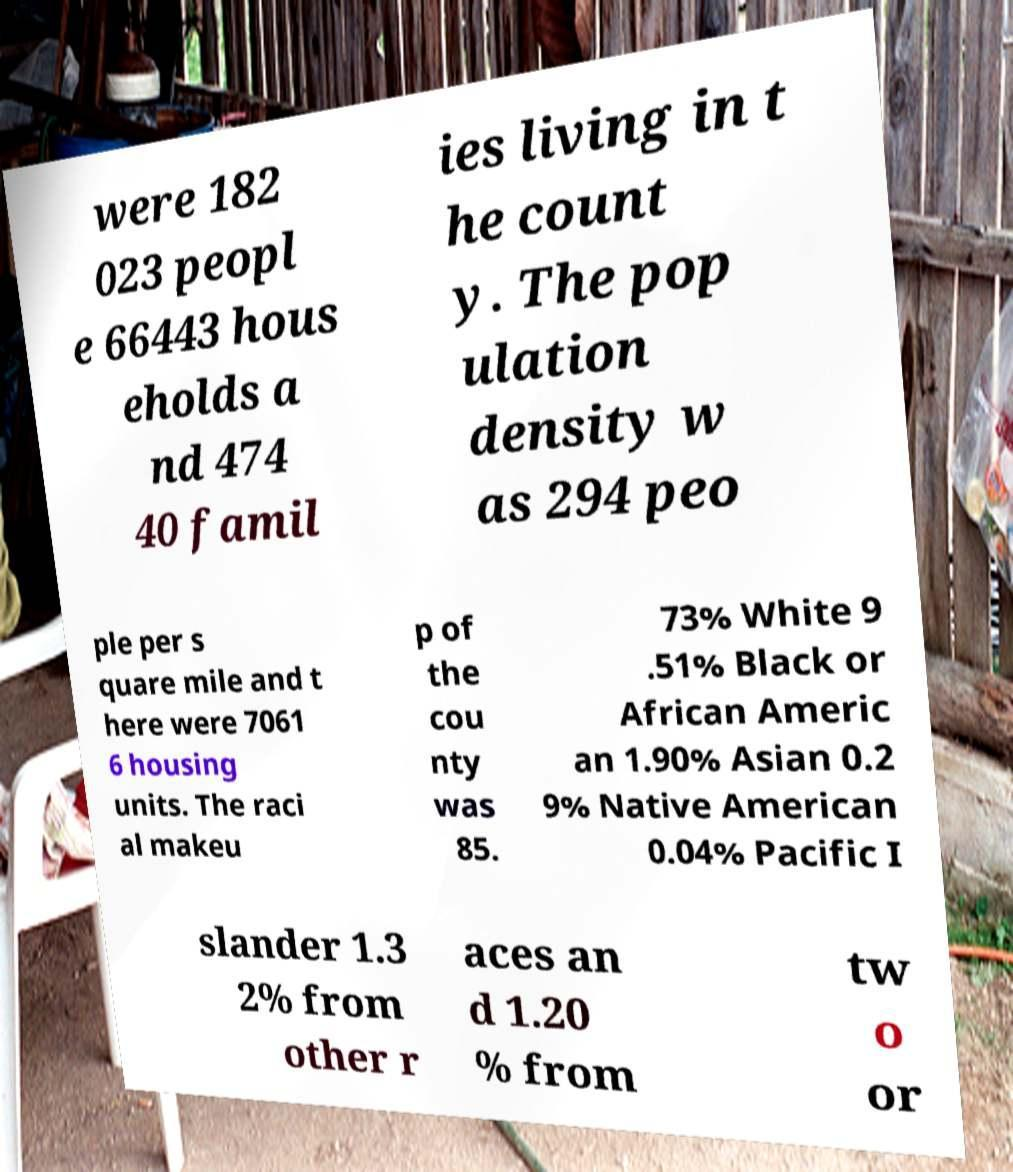Could you extract and type out the text from this image? were 182 023 peopl e 66443 hous eholds a nd 474 40 famil ies living in t he count y. The pop ulation density w as 294 peo ple per s quare mile and t here were 7061 6 housing units. The raci al makeu p of the cou nty was 85. 73% White 9 .51% Black or African Americ an 1.90% Asian 0.2 9% Native American 0.04% Pacific I slander 1.3 2% from other r aces an d 1.20 % from tw o or 